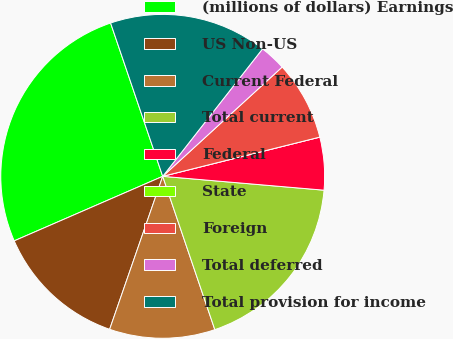<chart> <loc_0><loc_0><loc_500><loc_500><pie_chart><fcel>(millions of dollars) Earnings<fcel>US Non-US<fcel>Current Federal<fcel>Total current<fcel>Federal<fcel>State<fcel>Foreign<fcel>Total deferred<fcel>Total provision for income<nl><fcel>26.31%<fcel>13.16%<fcel>10.53%<fcel>18.42%<fcel>5.26%<fcel>0.0%<fcel>7.9%<fcel>2.63%<fcel>15.79%<nl></chart> 